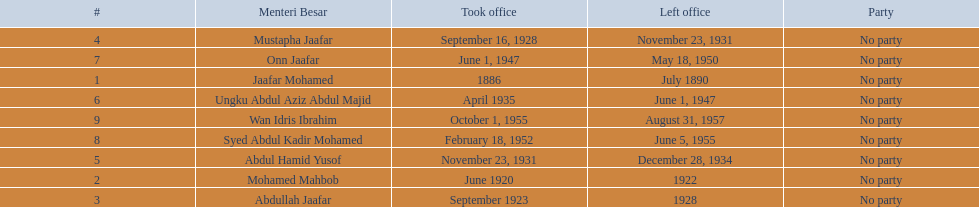Can you give me this table as a dict? {'header': ['#', 'Menteri Besar', 'Took office', 'Left office', 'Party'], 'rows': [['4', 'Mustapha Jaafar', 'September 16, 1928', 'November 23, 1931', 'No party'], ['7', 'Onn Jaafar', 'June 1, 1947', 'May 18, 1950', 'No party'], ['1', 'Jaafar Mohamed', '1886', 'July 1890', 'No party'], ['6', 'Ungku Abdul Aziz Abdul Majid', 'April 1935', 'June 1, 1947', 'No party'], ['9', 'Wan Idris Ibrahim', 'October 1, 1955', 'August 31, 1957', 'No party'], ['8', 'Syed Abdul Kadir Mohamed', 'February 18, 1952', 'June 5, 1955', 'No party'], ['5', 'Abdul Hamid Yusof', 'November 23, 1931', 'December 28, 1934', 'No party'], ['2', 'Mohamed Mahbob', 'June 1920', '1922', 'No party'], ['3', 'Abdullah Jaafar', 'September 1923', '1928', 'No party']]} Who were all of the menteri besars? Jaafar Mohamed, Mohamed Mahbob, Abdullah Jaafar, Mustapha Jaafar, Abdul Hamid Yusof, Ungku Abdul Aziz Abdul Majid, Onn Jaafar, Syed Abdul Kadir Mohamed, Wan Idris Ibrahim. When did they take office? 1886, June 1920, September 1923, September 16, 1928, November 23, 1931, April 1935, June 1, 1947, February 18, 1952, October 1, 1955. And when did they leave? July 1890, 1922, 1928, November 23, 1931, December 28, 1934, June 1, 1947, May 18, 1950, June 5, 1955, August 31, 1957. Now, who was in office for less than four years? Mohamed Mahbob. 